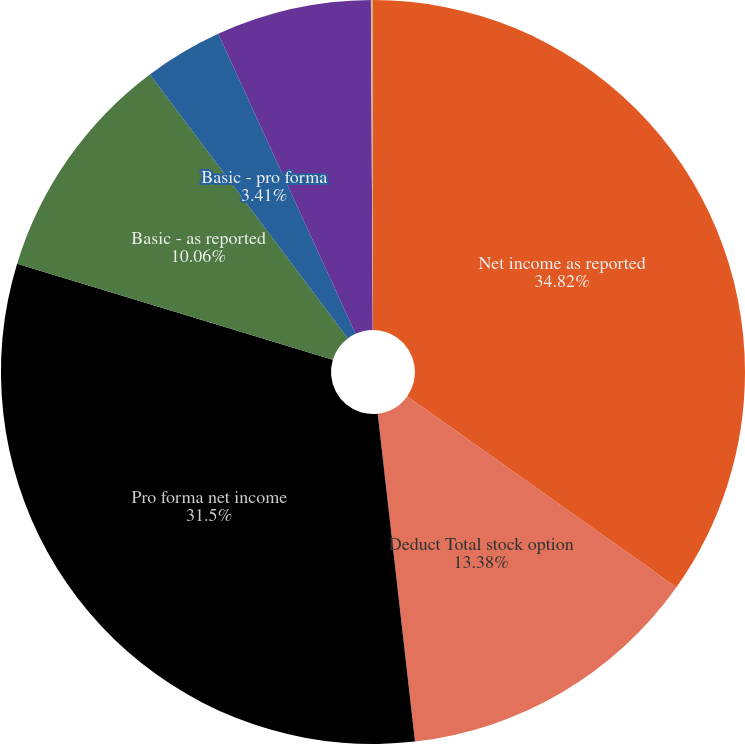<chart> <loc_0><loc_0><loc_500><loc_500><pie_chart><fcel>Net income as reported<fcel>Deduct Total stock option<fcel>Pro forma net income<fcel>Basic - as reported<fcel>Basic - pro forma<fcel>Diluted - as reported<fcel>Diluted - pro forma<nl><fcel>34.82%<fcel>13.38%<fcel>31.5%<fcel>10.06%<fcel>3.41%<fcel>6.74%<fcel>0.09%<nl></chart> 